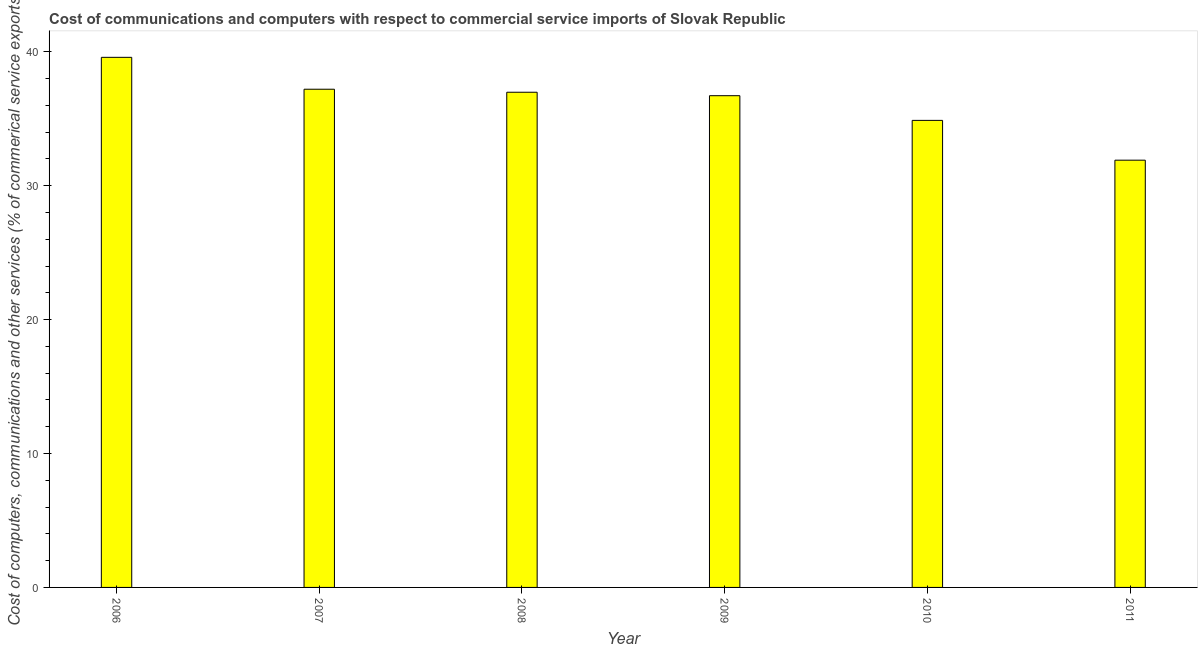What is the title of the graph?
Keep it short and to the point. Cost of communications and computers with respect to commercial service imports of Slovak Republic. What is the label or title of the X-axis?
Provide a short and direct response. Year. What is the label or title of the Y-axis?
Provide a succinct answer. Cost of computers, communications and other services (% of commerical service exports). What is the cost of communications in 2007?
Keep it short and to the point. 37.2. Across all years, what is the maximum  computer and other services?
Make the answer very short. 39.58. Across all years, what is the minimum  computer and other services?
Your response must be concise. 31.9. What is the sum of the  computer and other services?
Ensure brevity in your answer.  217.25. What is the difference between the  computer and other services in 2010 and 2011?
Your response must be concise. 2.97. What is the average  computer and other services per year?
Your answer should be very brief. 36.21. What is the median  computer and other services?
Your answer should be very brief. 36.85. What is the ratio of the  computer and other services in 2008 to that in 2011?
Offer a terse response. 1.16. What is the difference between the highest and the second highest cost of communications?
Keep it short and to the point. 2.38. What is the difference between the highest and the lowest cost of communications?
Your answer should be compact. 7.68. How many bars are there?
Your answer should be compact. 6. Are all the bars in the graph horizontal?
Your answer should be very brief. No. How many years are there in the graph?
Give a very brief answer. 6. Are the values on the major ticks of Y-axis written in scientific E-notation?
Offer a terse response. No. What is the Cost of computers, communications and other services (% of commerical service exports) in 2006?
Make the answer very short. 39.58. What is the Cost of computers, communications and other services (% of commerical service exports) in 2007?
Make the answer very short. 37.2. What is the Cost of computers, communications and other services (% of commerical service exports) in 2008?
Offer a very short reply. 36.97. What is the Cost of computers, communications and other services (% of commerical service exports) of 2009?
Your answer should be compact. 36.72. What is the Cost of computers, communications and other services (% of commerical service exports) in 2010?
Make the answer very short. 34.87. What is the Cost of computers, communications and other services (% of commerical service exports) of 2011?
Make the answer very short. 31.9. What is the difference between the Cost of computers, communications and other services (% of commerical service exports) in 2006 and 2007?
Your answer should be compact. 2.38. What is the difference between the Cost of computers, communications and other services (% of commerical service exports) in 2006 and 2008?
Offer a terse response. 2.61. What is the difference between the Cost of computers, communications and other services (% of commerical service exports) in 2006 and 2009?
Provide a short and direct response. 2.86. What is the difference between the Cost of computers, communications and other services (% of commerical service exports) in 2006 and 2010?
Keep it short and to the point. 4.71. What is the difference between the Cost of computers, communications and other services (% of commerical service exports) in 2006 and 2011?
Provide a succinct answer. 7.68. What is the difference between the Cost of computers, communications and other services (% of commerical service exports) in 2007 and 2008?
Keep it short and to the point. 0.23. What is the difference between the Cost of computers, communications and other services (% of commerical service exports) in 2007 and 2009?
Make the answer very short. 0.48. What is the difference between the Cost of computers, communications and other services (% of commerical service exports) in 2007 and 2010?
Make the answer very short. 2.33. What is the difference between the Cost of computers, communications and other services (% of commerical service exports) in 2007 and 2011?
Your answer should be very brief. 5.3. What is the difference between the Cost of computers, communications and other services (% of commerical service exports) in 2008 and 2009?
Give a very brief answer. 0.26. What is the difference between the Cost of computers, communications and other services (% of commerical service exports) in 2008 and 2010?
Make the answer very short. 2.1. What is the difference between the Cost of computers, communications and other services (% of commerical service exports) in 2008 and 2011?
Offer a very short reply. 5.07. What is the difference between the Cost of computers, communications and other services (% of commerical service exports) in 2009 and 2010?
Provide a short and direct response. 1.84. What is the difference between the Cost of computers, communications and other services (% of commerical service exports) in 2009 and 2011?
Offer a very short reply. 4.81. What is the difference between the Cost of computers, communications and other services (% of commerical service exports) in 2010 and 2011?
Offer a terse response. 2.97. What is the ratio of the Cost of computers, communications and other services (% of commerical service exports) in 2006 to that in 2007?
Offer a very short reply. 1.06. What is the ratio of the Cost of computers, communications and other services (% of commerical service exports) in 2006 to that in 2008?
Your answer should be compact. 1.07. What is the ratio of the Cost of computers, communications and other services (% of commerical service exports) in 2006 to that in 2009?
Ensure brevity in your answer.  1.08. What is the ratio of the Cost of computers, communications and other services (% of commerical service exports) in 2006 to that in 2010?
Your response must be concise. 1.14. What is the ratio of the Cost of computers, communications and other services (% of commerical service exports) in 2006 to that in 2011?
Your answer should be compact. 1.24. What is the ratio of the Cost of computers, communications and other services (% of commerical service exports) in 2007 to that in 2008?
Offer a terse response. 1.01. What is the ratio of the Cost of computers, communications and other services (% of commerical service exports) in 2007 to that in 2009?
Ensure brevity in your answer.  1.01. What is the ratio of the Cost of computers, communications and other services (% of commerical service exports) in 2007 to that in 2010?
Make the answer very short. 1.07. What is the ratio of the Cost of computers, communications and other services (% of commerical service exports) in 2007 to that in 2011?
Ensure brevity in your answer.  1.17. What is the ratio of the Cost of computers, communications and other services (% of commerical service exports) in 2008 to that in 2010?
Give a very brief answer. 1.06. What is the ratio of the Cost of computers, communications and other services (% of commerical service exports) in 2008 to that in 2011?
Provide a succinct answer. 1.16. What is the ratio of the Cost of computers, communications and other services (% of commerical service exports) in 2009 to that in 2010?
Ensure brevity in your answer.  1.05. What is the ratio of the Cost of computers, communications and other services (% of commerical service exports) in 2009 to that in 2011?
Ensure brevity in your answer.  1.15. What is the ratio of the Cost of computers, communications and other services (% of commerical service exports) in 2010 to that in 2011?
Make the answer very short. 1.09. 